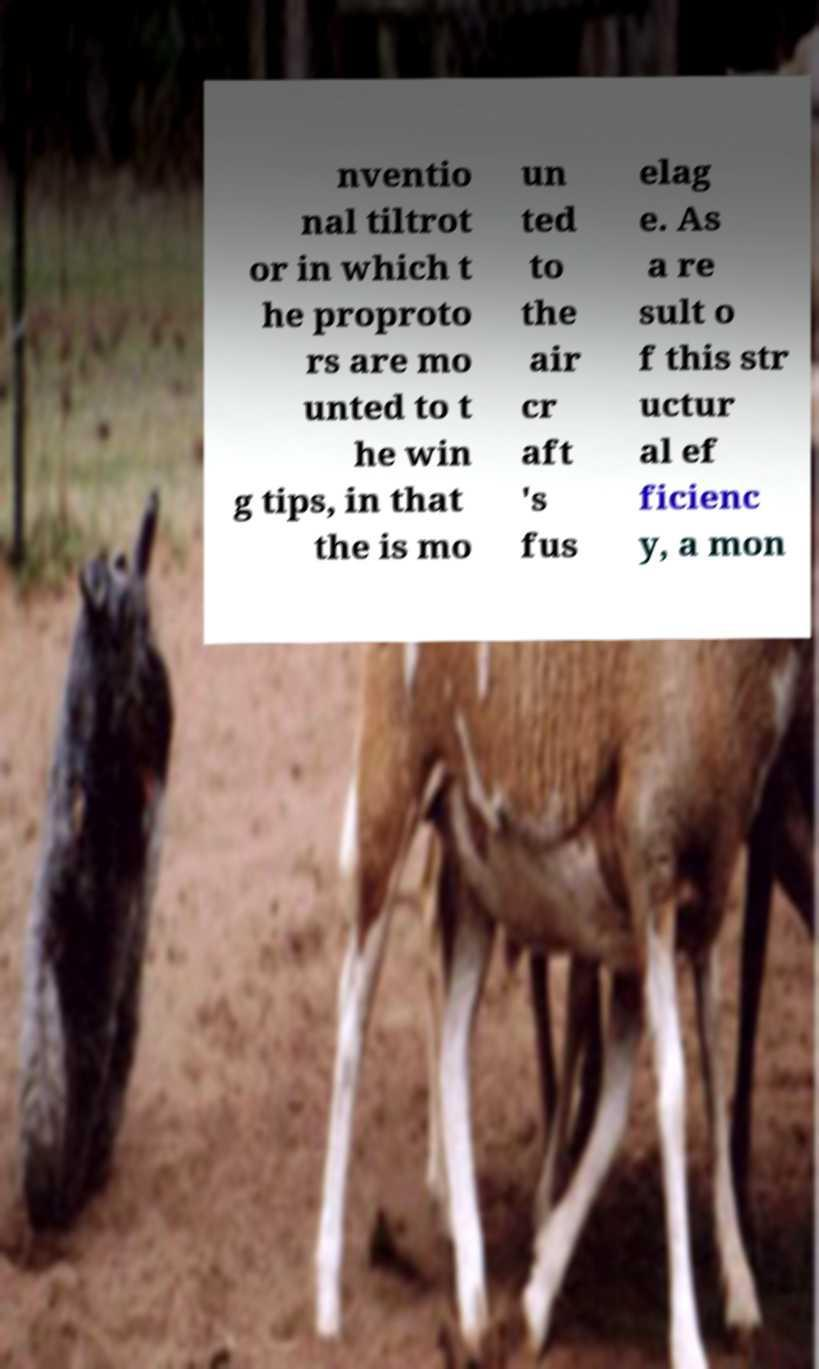For documentation purposes, I need the text within this image transcribed. Could you provide that? nventio nal tiltrot or in which t he proproto rs are mo unted to t he win g tips, in that the is mo un ted to the air cr aft 's fus elag e. As a re sult o f this str uctur al ef ficienc y, a mon 